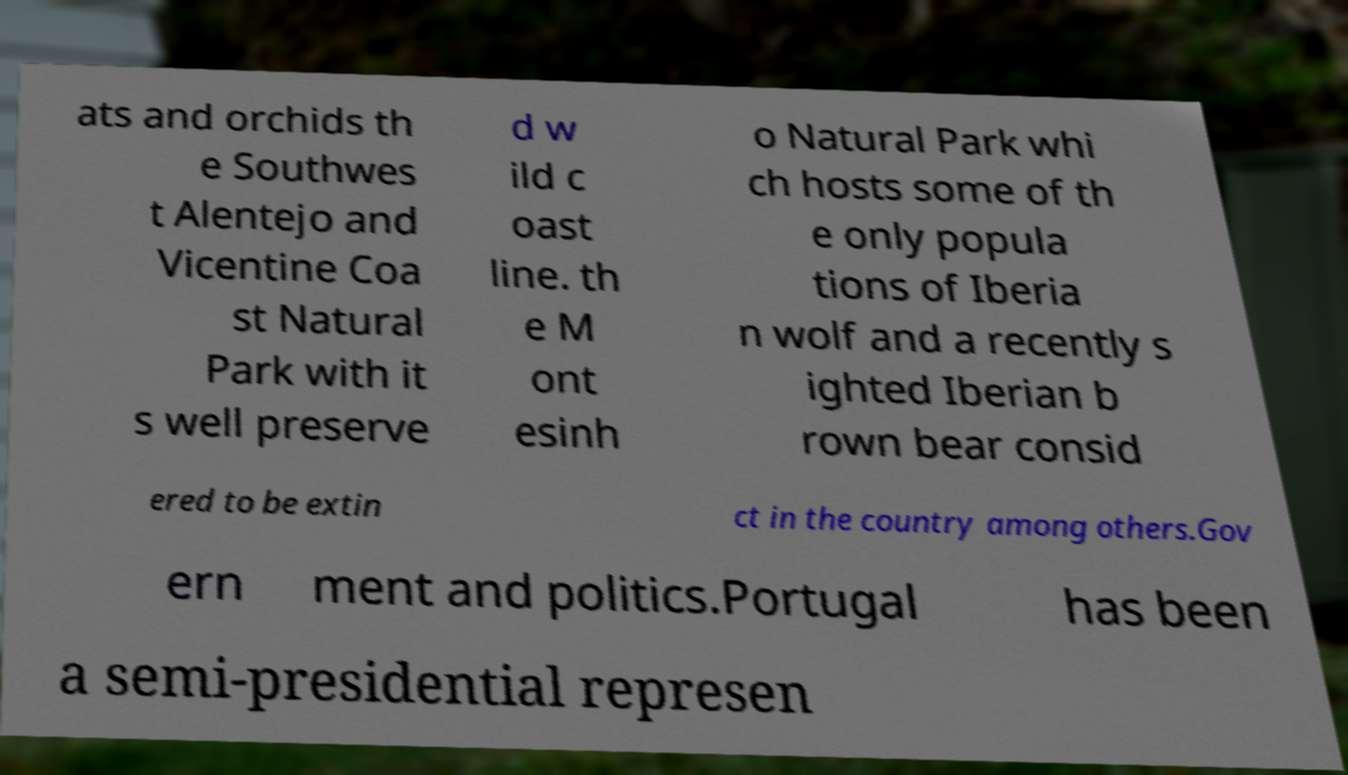Please read and relay the text visible in this image. What does it say? ats and orchids th e Southwes t Alentejo and Vicentine Coa st Natural Park with it s well preserve d w ild c oast line. th e M ont esinh o Natural Park whi ch hosts some of th e only popula tions of Iberia n wolf and a recently s ighted Iberian b rown bear consid ered to be extin ct in the country among others.Gov ern ment and politics.Portugal has been a semi-presidential represen 